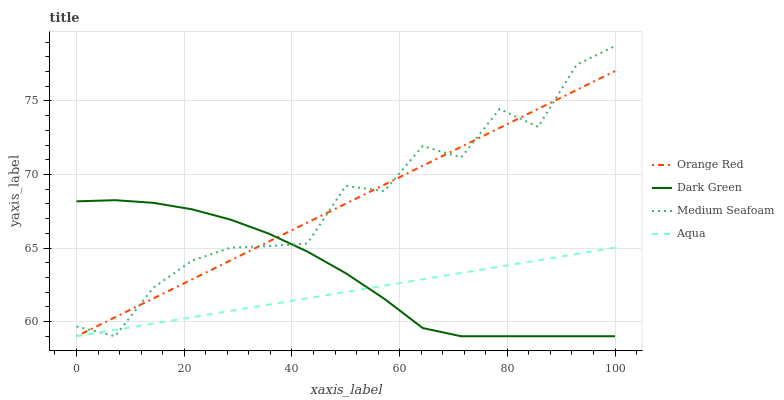Does Aqua have the minimum area under the curve?
Answer yes or no. Yes. Does Medium Seafoam have the maximum area under the curve?
Answer yes or no. Yes. Does Orange Red have the minimum area under the curve?
Answer yes or no. No. Does Orange Red have the maximum area under the curve?
Answer yes or no. No. Is Orange Red the smoothest?
Answer yes or no. Yes. Is Medium Seafoam the roughest?
Answer yes or no. Yes. Is Aqua the smoothest?
Answer yes or no. No. Is Aqua the roughest?
Answer yes or no. No. Does Medium Seafoam have the lowest value?
Answer yes or no. Yes. Does Medium Seafoam have the highest value?
Answer yes or no. Yes. Does Orange Red have the highest value?
Answer yes or no. No. Does Orange Red intersect Medium Seafoam?
Answer yes or no. Yes. Is Orange Red less than Medium Seafoam?
Answer yes or no. No. Is Orange Red greater than Medium Seafoam?
Answer yes or no. No. 